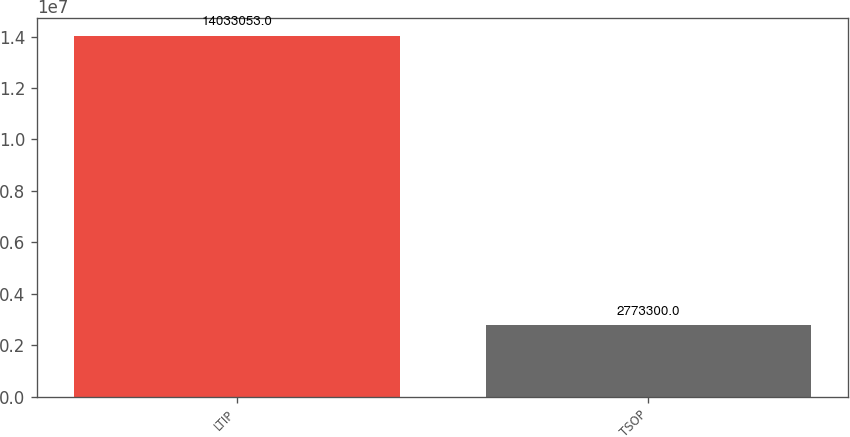Convert chart to OTSL. <chart><loc_0><loc_0><loc_500><loc_500><bar_chart><fcel>LTIP<fcel>TSOP<nl><fcel>1.40331e+07<fcel>2.7733e+06<nl></chart> 